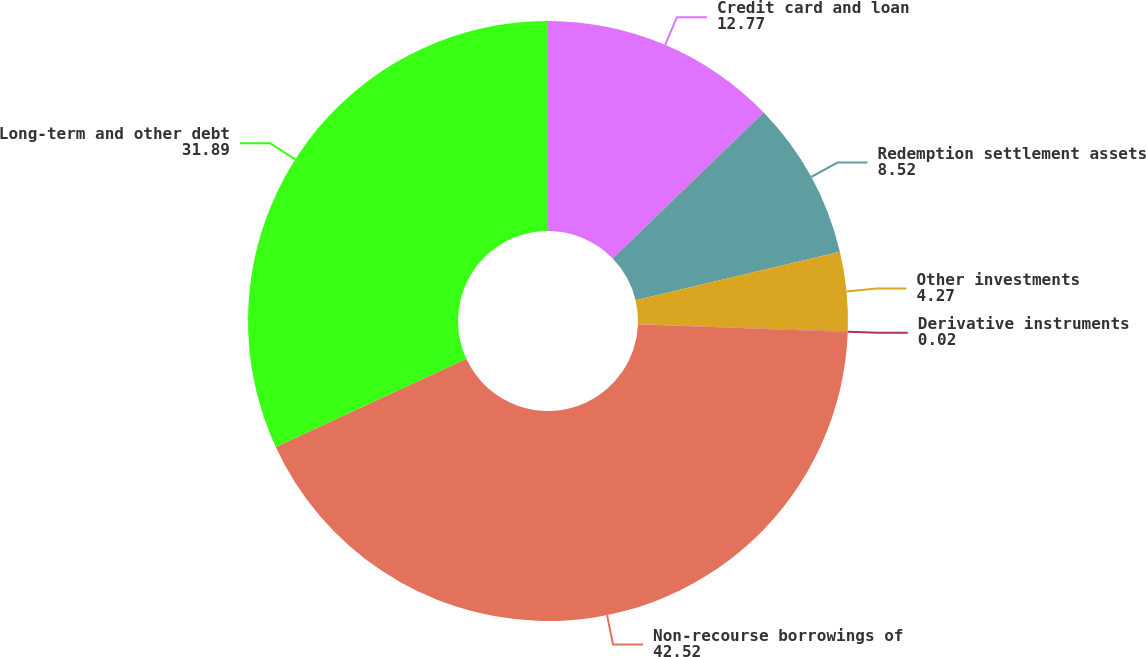Convert chart. <chart><loc_0><loc_0><loc_500><loc_500><pie_chart><fcel>Credit card and loan<fcel>Redemption settlement assets<fcel>Other investments<fcel>Derivative instruments<fcel>Non-recourse borrowings of<fcel>Long-term and other debt<nl><fcel>12.77%<fcel>8.52%<fcel>4.27%<fcel>0.02%<fcel>42.52%<fcel>31.89%<nl></chart> 